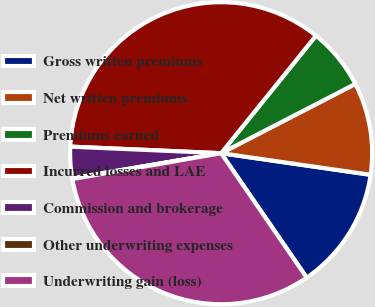Convert chart. <chart><loc_0><loc_0><loc_500><loc_500><pie_chart><fcel>Gross written premiums<fcel>Net written premiums<fcel>Premiums earned<fcel>Incurred losses and LAE<fcel>Commission and brokerage<fcel>Other underwriting expenses<fcel>Underwriting gain (loss)<nl><fcel>13.13%<fcel>9.87%<fcel>6.61%<fcel>35.11%<fcel>3.35%<fcel>0.08%<fcel>31.85%<nl></chart> 